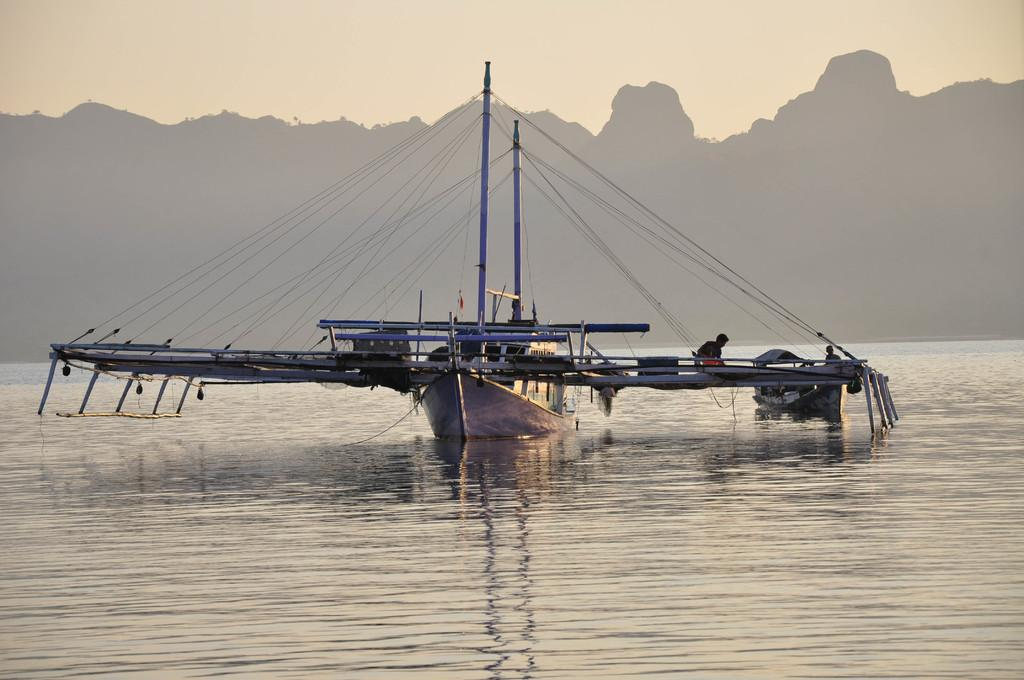What is the main subject of the image? The main subject of the image is boats on water. What else can be seen in the image besides the boats? There are poles, two people, some objects, mountains, and the sky visible in the image. Can you describe the people in the image? There are two people in the image, but their specific actions or appearances are not mentioned in the facts. What is the background of the image like? The background of the image includes mountains and the sky. Where is the throne located in the image? There is no throne present in the image. What type of screw can be seen holding the boats together in the image? There are no screws visible in the image; the boats are on water, not connected by screws. 